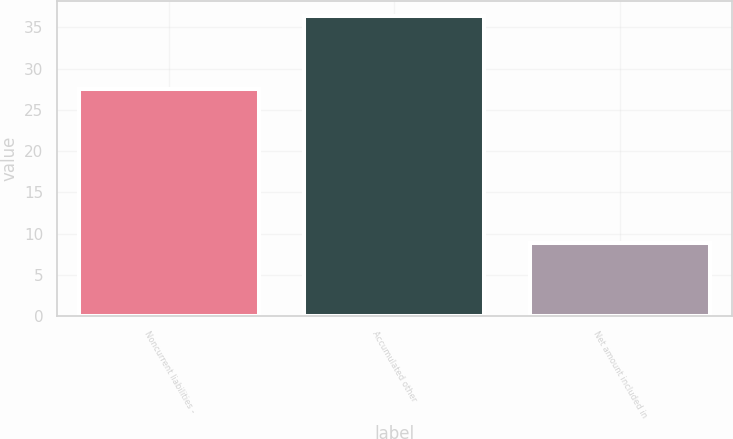Convert chart. <chart><loc_0><loc_0><loc_500><loc_500><bar_chart><fcel>Noncurrent liabilities -<fcel>Accumulated other<fcel>Net amount included in<nl><fcel>27.5<fcel>36.4<fcel>8.9<nl></chart> 